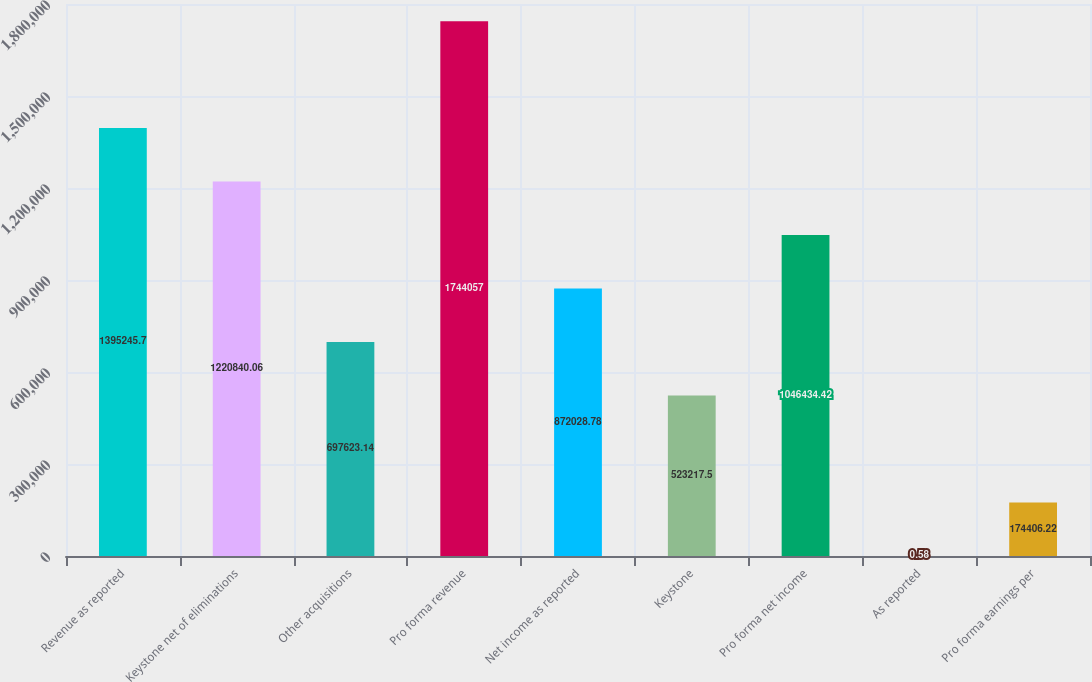Convert chart. <chart><loc_0><loc_0><loc_500><loc_500><bar_chart><fcel>Revenue as reported<fcel>Keystone net of eliminations<fcel>Other acquisitions<fcel>Pro forma revenue<fcel>Net income as reported<fcel>Keystone<fcel>Pro forma net income<fcel>As reported<fcel>Pro forma earnings per<nl><fcel>1.39525e+06<fcel>1.22084e+06<fcel>697623<fcel>1.74406e+06<fcel>872029<fcel>523218<fcel>1.04643e+06<fcel>0.58<fcel>174406<nl></chart> 